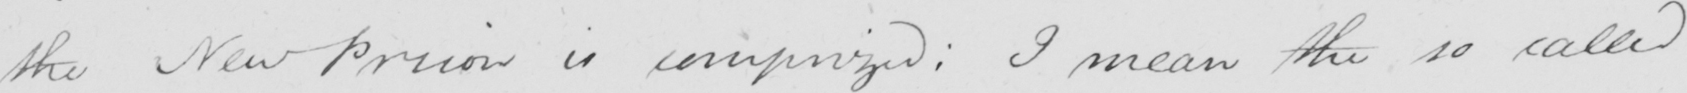Please provide the text content of this handwritten line. the New Prison is comprized :  I mean the so called 